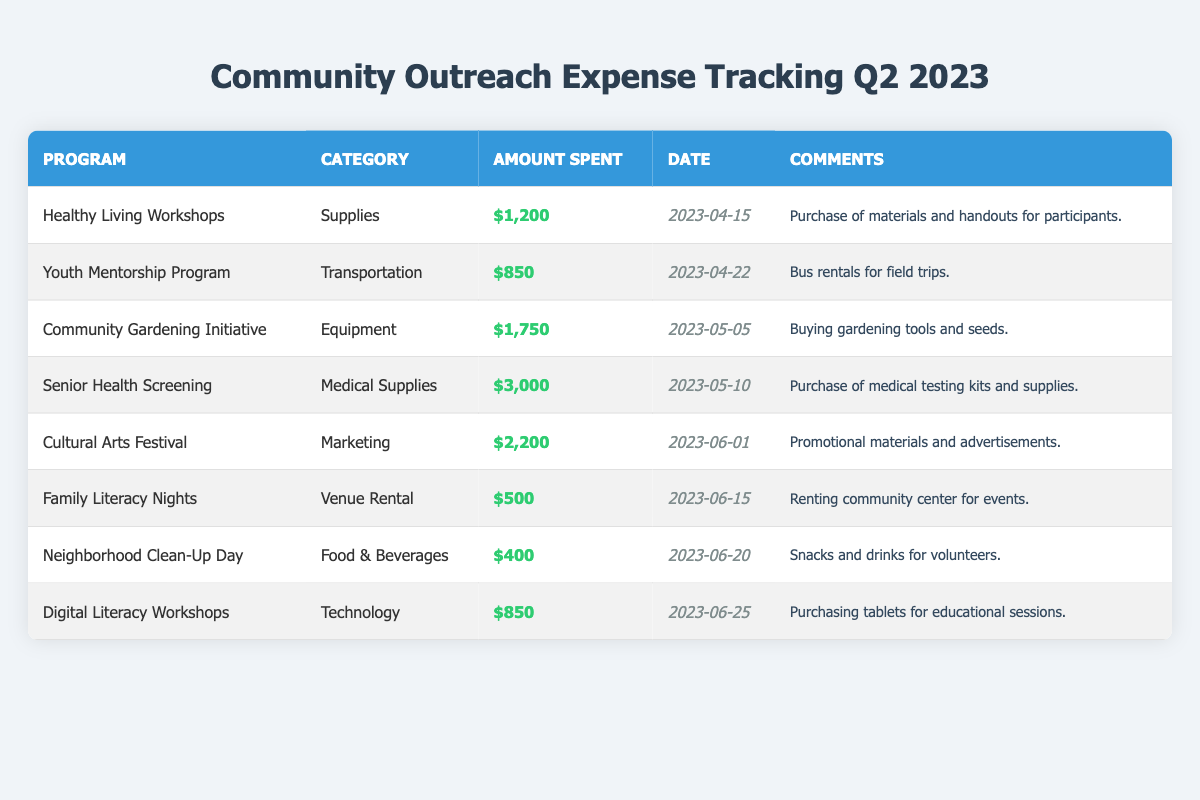What was the highest amount spent in a single program? The highest amount can be found by scanning the "Amount Spent" column. The entry for "Senior Health Screening" shows the highest value at $3,000.
Answer: $3,000 Which program had the least expenditure? By looking through the entries, "Neighborhood Clean-Up Day" shows an expenditure of $400, which is the lowest amount spent among all programs listed.
Answer: $400 What is the total amount spent across all programs? To find the total amount, add together all the amounts listed: $1,200 + $850 + $1,750 + $3,000 + $2,200 + $500 + $400 + $850 = $10,000.
Answer: $10,000 Was there any expenditure on marketing for the programs? The "Cultural Arts Festival" is noted under the "Marketing" category with an amount spent of $2,200. Therefore, there was indeed a marketing expenditure.
Answer: Yes How many programs had expenditures above $1,000? Assessing the table, the programs exceeding $1,000 in spending are: "Healthy Living Workshops," "Community Gardening Initiative," "Senior Health Screening," and "Cultural Arts Festival," totaling four programs.
Answer: 4 What percentage of the total spending is attributed to the "Senior Health Screening" program? First, determine the amount spent on the "Senior Health Screening," which is $3,000. The total is $10,000. The percentage can be calculated as ($3,000 / $10,000) * 100 = 30%.
Answer: 30% Which category had the highest total spending? Tally the amounts in each category: Supplies: $1,200, Transportation: $850, Equipment: $1,750, Medical Supplies: $3,000, Marketing: $2,200, Venue Rental: $500, Food & Beverages: $400, Technology: $850. The highest total, $3,000, is for Medical Supplies.
Answer: Medical Supplies Are there any programs that did not involve spending on technology? Evaluating the table, all programs except "Digital Literacy Workshops," which is the only technology expenditure, do not involve technology. Thus, the majority did not include technology spending.
Answer: Yes What is the average amount spent per program? There are eight programs listed. The total spending is $10,000. Therefore, the average amount spent is $10,000 / 8 = $1,250.
Answer: $1,250 Which program took place the latest in the quarter? Checking the dates, "Digital Literacy Workshops" on June 25, 2023, has the latest date, indicating it took place last in the quarter.
Answer: Digital Literacy Workshops How much was spent on food and beverages? The entry for "Neighborhood Clean-Up Day" indicates that $400 was spent in the "Food & Beverages" category.
Answer: $400 